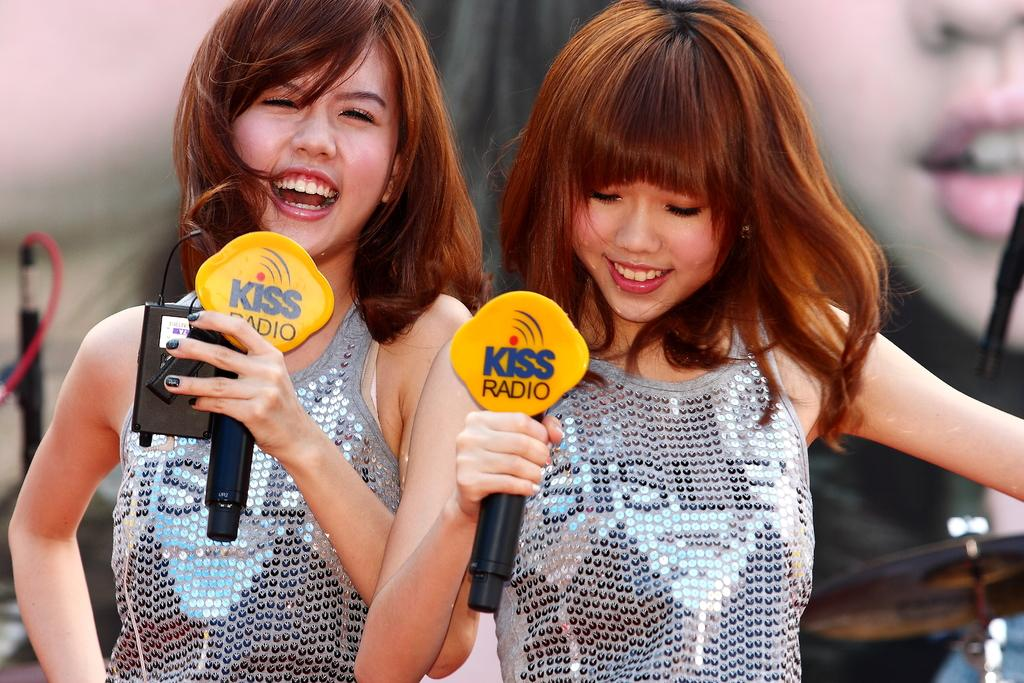How many people are in the image? There are two girls in the image. What are the girls holding in their hands? The girls are holding microphones in their hands. What expression do the girls have in the image? Both girls are smiling. What type of comb is the girl using to style her hair in the image? There is no comb visible in the image, and the girls are not shown styling their hair. 